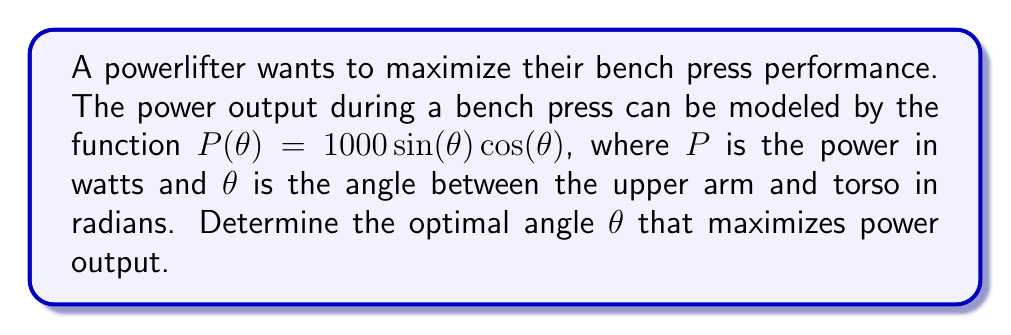What is the answer to this math problem? To find the optimal angle for maximum power output, we need to follow these steps:

1) The given function is $P(\theta) = 1000 \sin(\theta) \cos(\theta)$

2) To find the maximum, we need to differentiate $P(\theta)$ with respect to $\theta$ and set it to zero:

   $$\frac{dP}{d\theta} = 1000 (\cos^2(\theta) - \sin^2(\theta))$$

3) Set this equal to zero:

   $$1000 (\cos^2(\theta) - \sin^2(\theta)) = 0$$

4) Simplify:

   $$\cos^2(\theta) - \sin^2(\theta) = 0$$

5) Recall the trigonometric identity $\cos(2\theta) = \cos^2(\theta) - \sin^2(\theta)$

6) Therefore, our equation becomes:

   $$\cos(2\theta) = 0$$

7) The solutions to this equation are:

   $$2\theta = \frac{\pi}{2} + \pi n, \text{ where } n \text{ is an integer}$$

8) Solving for $\theta$:

   $$\theta = \frac{\pi}{4} + \frac{\pi n}{2}$$

9) The smallest positive solution is when $n = 0$:

   $$\theta = \frac{\pi}{4} \text{ radians}$$

10) To confirm this is a maximum (not a minimum), we can check the second derivative:

    $$\frac{d^2P}{d\theta^2} = -2000 \sin(\theta) \cos(\theta)$$

    At $\theta = \frac{\pi}{4}$, this is negative, confirming a maximum.

11) Convert to degrees:

    $$\frac{\pi}{4} \text{ radians} = 45°$$
Answer: 45° 